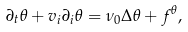Convert formula to latex. <formula><loc_0><loc_0><loc_500><loc_500>\partial _ { t } \theta + v _ { i } \partial _ { i } \theta = \nu _ { 0 } \Delta \theta + f ^ { \theta } ,</formula> 